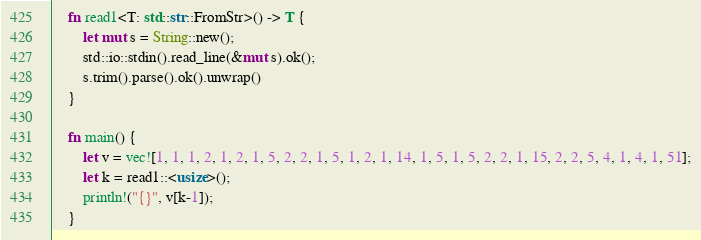Convert code to text. <code><loc_0><loc_0><loc_500><loc_500><_Rust_>    fn read1<T: std::str::FromStr>() -> T {
        let mut s = String::new();
        std::io::stdin().read_line(&mut s).ok();
        s.trim().parse().ok().unwrap()
    }
     
    fn main() {
        let v = vec![1, 1, 1, 2, 1, 2, 1, 5, 2, 2, 1, 5, 1, 2, 1, 14, 1, 5, 1, 5, 2, 2, 1, 15, 2, 2, 5, 4, 1, 4, 1, 51];
        let k = read1::<usize>();
        println!("{}", v[k-1]);
    }</code> 